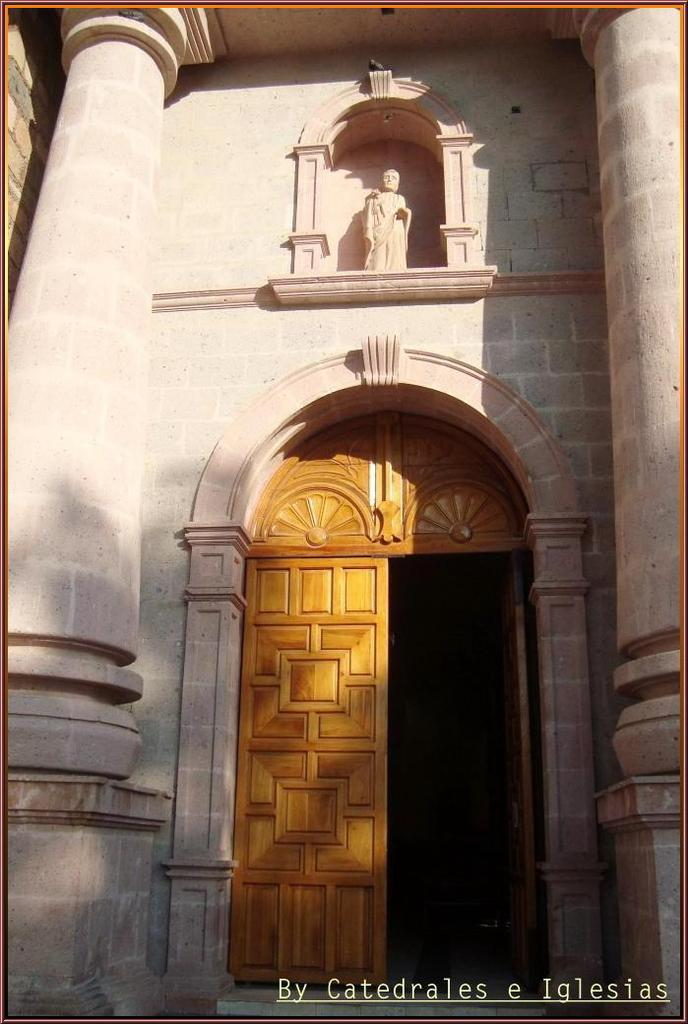What type of structures are visible in the image? There are houses in the image. What are some features of the houses? The houses have walls, pillars, and doors. Are there any other objects or features in the image besides the houses? Yes, there is a sculpture in the image. Is there any text or marking visible in the image? Yes, there is a watermark at the bottom of the image. What type of bait is being used to catch fish in the image? There is no mention of fish or bait in the image; it features houses, a sculpture, and a watermark. Can you tell me how many faucets are visible in the image? There are no faucets present in the image. 